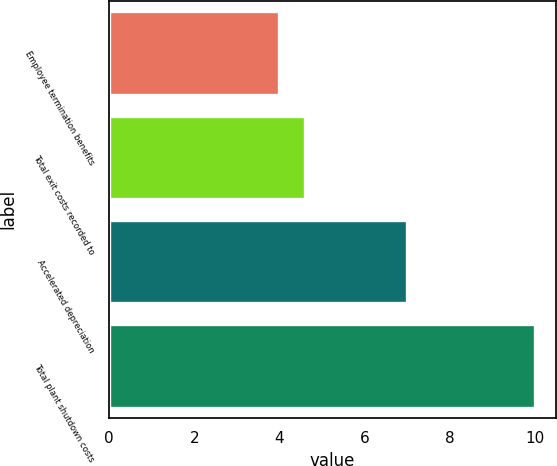Convert chart. <chart><loc_0><loc_0><loc_500><loc_500><bar_chart><fcel>Employee termination benefits<fcel>Total exit costs recorded to<fcel>Accelerated depreciation<fcel>Total plant shutdown costs<nl><fcel>4<fcel>4.6<fcel>7<fcel>10<nl></chart> 